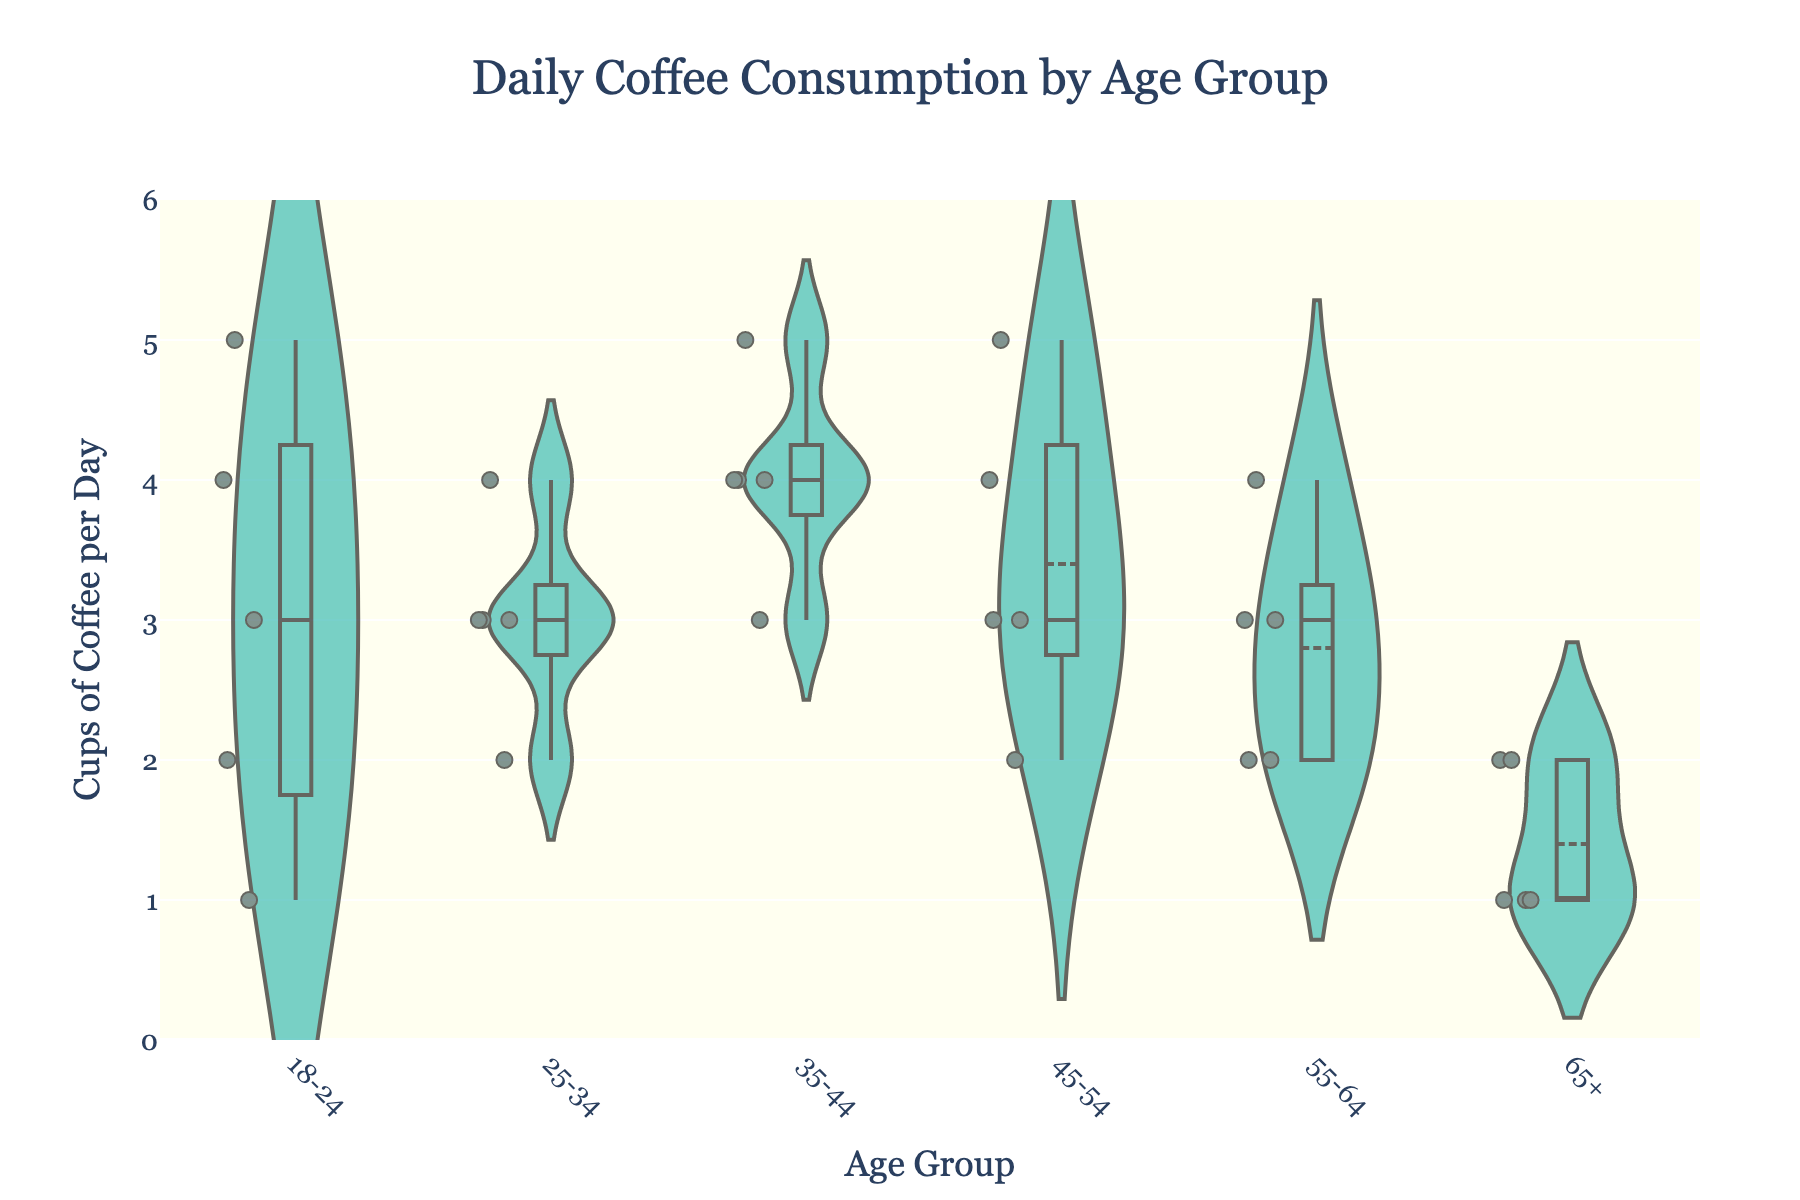What is the title of the figure? The title is typically displayed at the top of the figure in a larger and often bold font.
Answer: Daily Coffee Consumption by Age Group What colors are used for the fill of the violins and the box plots? The colors used can be seen directly on the figure. The violins are lightseagreen, and the box plots have a black line color.
Answer: Lightseagreen for violins, black for box plots How many age groups are represented in the figure? By counting the distinct labels along the x-axis, we can determine the number of age groups.
Answer: 6 Which age group has the highest median coffee consumption? The median is represented by the middle line in each box plot. Comparing these lines across all age groups identifies the highest one.
Answer: 35-44 What is the median coffee consumption for the 65+ age group? The median value is the center line in the box plot for the 65+ group.
Answer: 1 How does the maximum coffee consumption vary between the 18-24 and 45-54 age groups? Identify and compare the maximum value, represented by the top whisker, in the box plots for both age groups.
Answer: 5 for both What is the most common number of cups of coffee consumed per day by the 25-34 age group? The most common value is determined by the highest density area in the violin plot.
Answer: 3 Compare the interquartile ranges (IQR) of the 18-24 and 55-64 age groups. Which one has a larger IQR? The IQR is the range between the bottom and top of the box in the box plot. Calculate these ranges and compare.
Answer: 18-24 How many outliers are there in the 18-24 age group, and what are their values? Outliers are shown as points outside the whiskers of the box plot. Count these points and note their values.
Answer: 0 Which age group has the most variability in coffee consumption? Variability is often represented by the width of the violin plot and the range covered by the whiskers of the box plot. The widest and longest plots indicate the most variability.
Answer: 18-24 